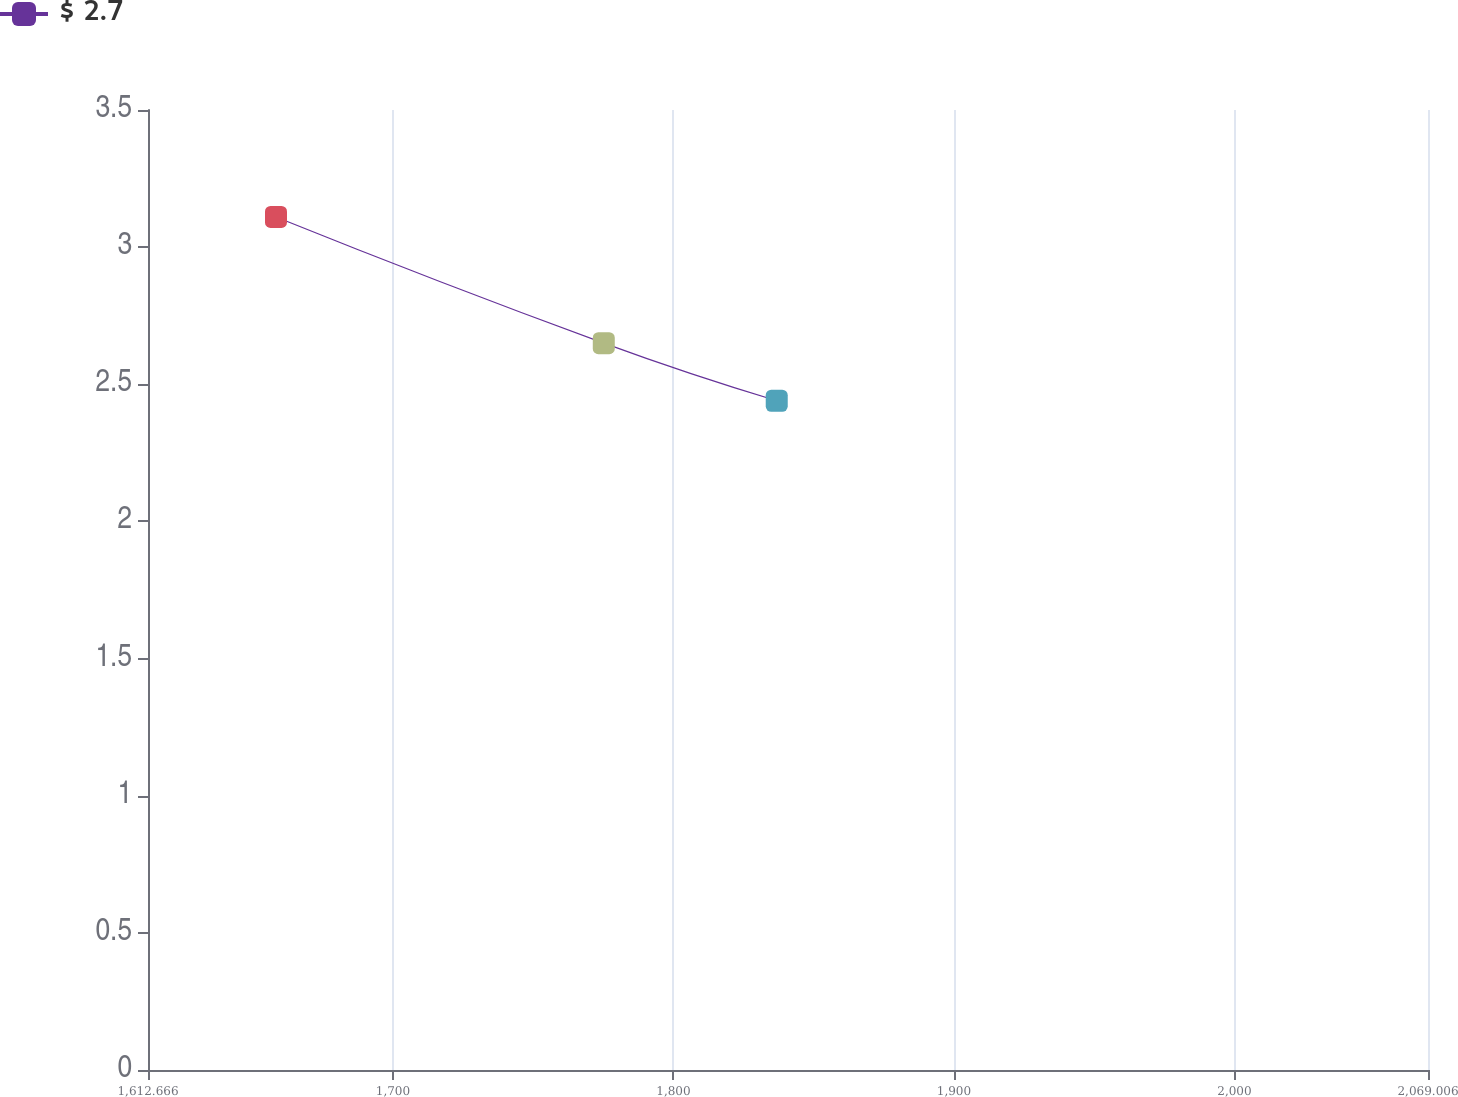Convert chart. <chart><loc_0><loc_0><loc_500><loc_500><line_chart><ecel><fcel>$ 2.7<nl><fcel>1658.3<fcel>3.11<nl><fcel>1775.16<fcel>2.65<nl><fcel>1836.82<fcel>2.44<nl><fcel>2114.64<fcel>2.8<nl></chart> 